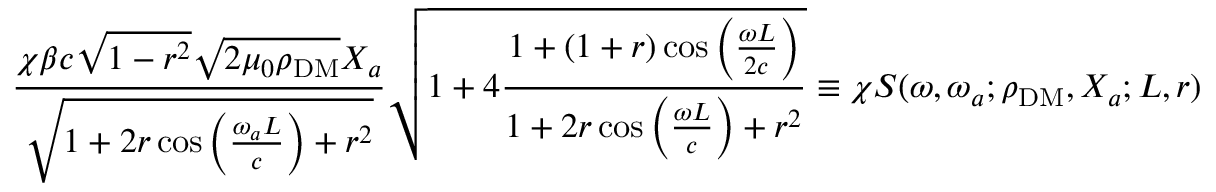Convert formula to latex. <formula><loc_0><loc_0><loc_500><loc_500>\frac { \chi \beta c \sqrt { 1 - r ^ { 2 } } \sqrt { 2 \mu _ { 0 } \rho _ { D M } } X _ { a } } { \sqrt { 1 + 2 r \cos \left ( \frac { \omega _ { a } L } { c } \right ) + r ^ { 2 } } } \sqrt { 1 + 4 \frac { 1 + ( 1 + r ) \cos \left ( \frac { \omega L } { 2 c } \right ) } { 1 + 2 r \cos \left ( \frac { \omega L } { c } \right ) + r ^ { 2 } } } \equiv \chi S ( \omega , \omega _ { a } ; \rho _ { D M } , X _ { a } ; L , r ) \, ,</formula> 